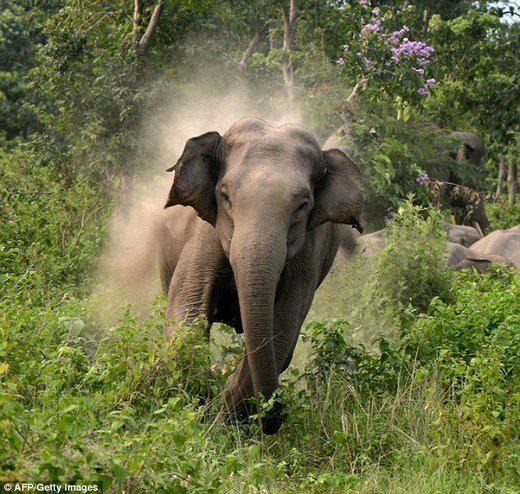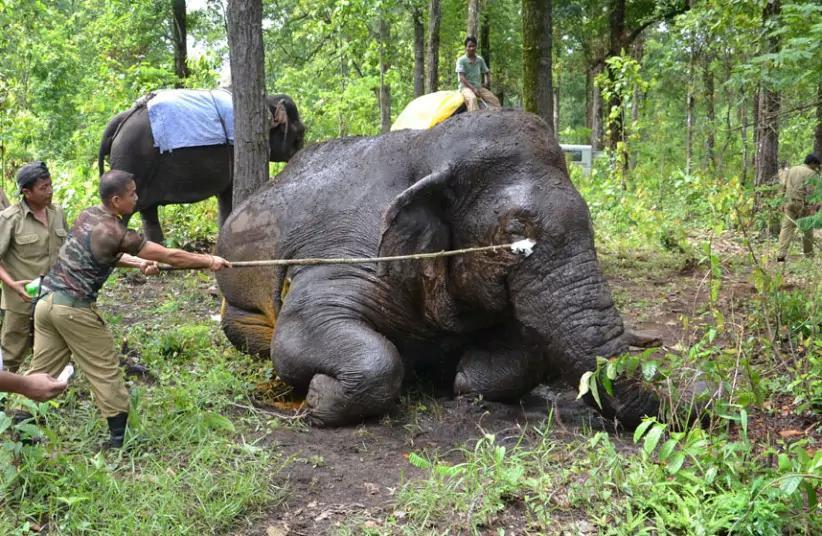The first image is the image on the left, the second image is the image on the right. Assess this claim about the two images: "Three elephants in total.". Correct or not? Answer yes or no. Yes. The first image is the image on the left, the second image is the image on the right. Evaluate the accuracy of this statement regarding the images: "One image shows an elephant with large tusks.". Is it true? Answer yes or no. No. 